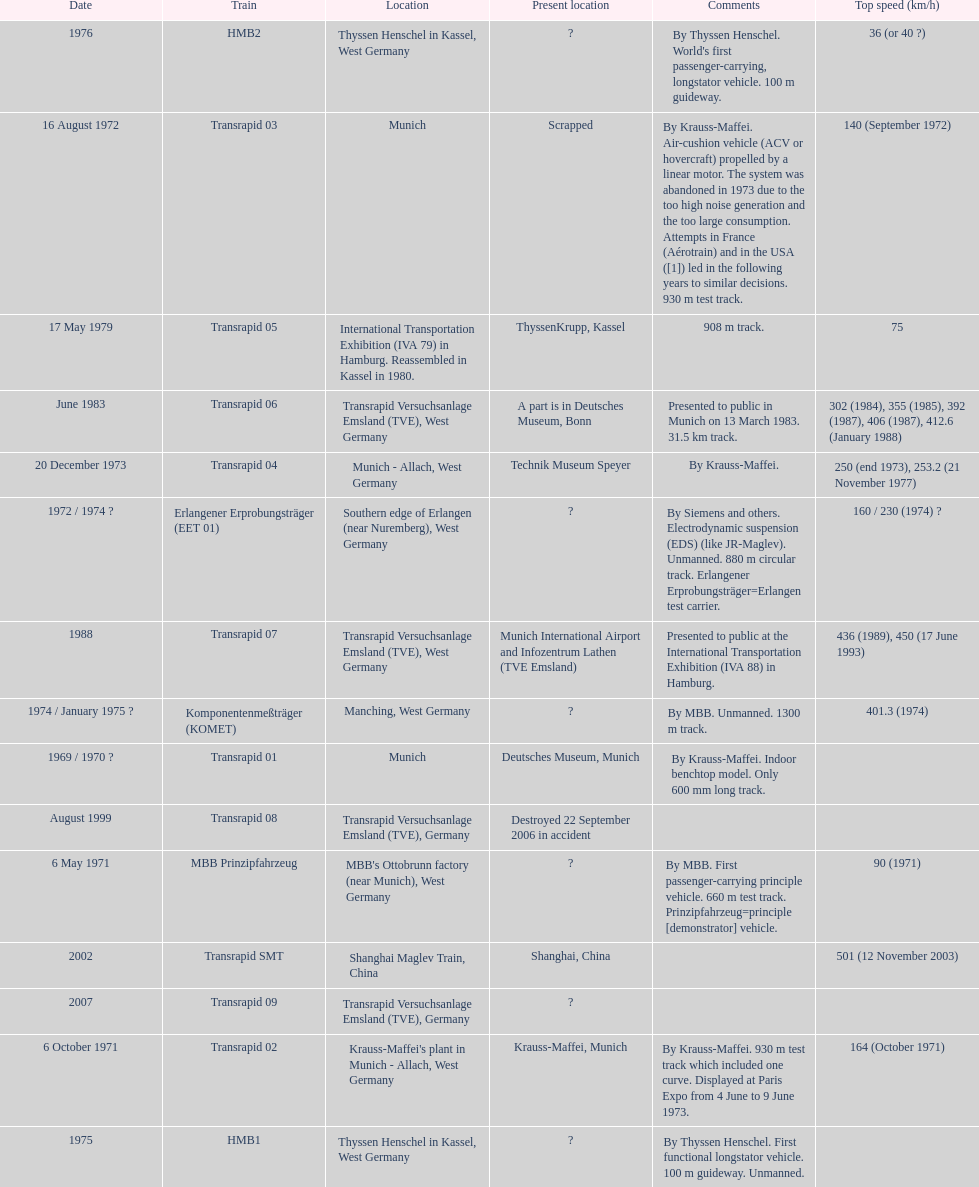What is the only train to reach a top speed of 500 or more? Transrapid SMT. 